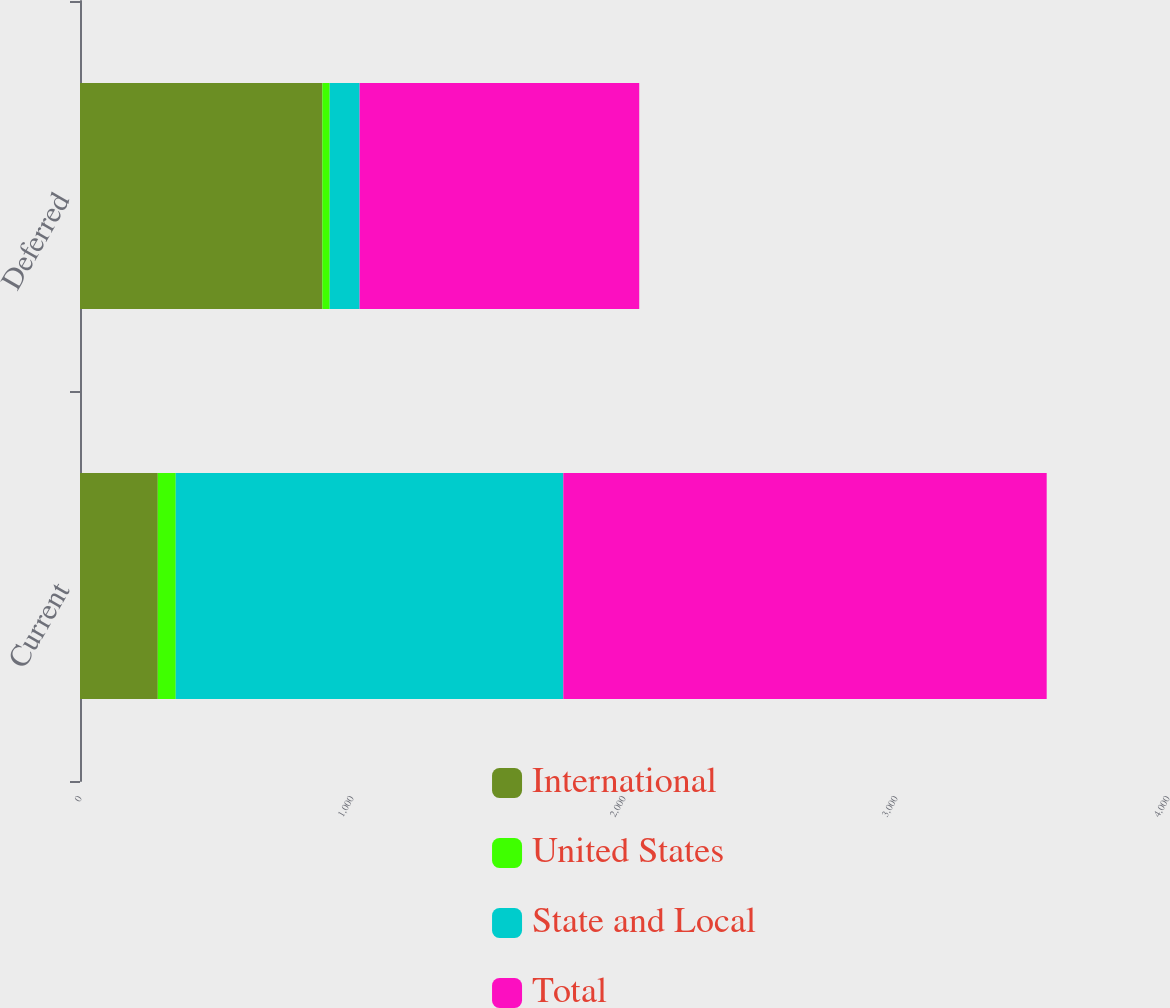<chart> <loc_0><loc_0><loc_500><loc_500><stacked_bar_chart><ecel><fcel>Current<fcel>Deferred<nl><fcel>International<fcel>286<fcel>891<nl><fcel>United States<fcel>66<fcel>27<nl><fcel>State and Local<fcel>1425<fcel>110<nl><fcel>Total<fcel>1777<fcel>1028<nl></chart> 